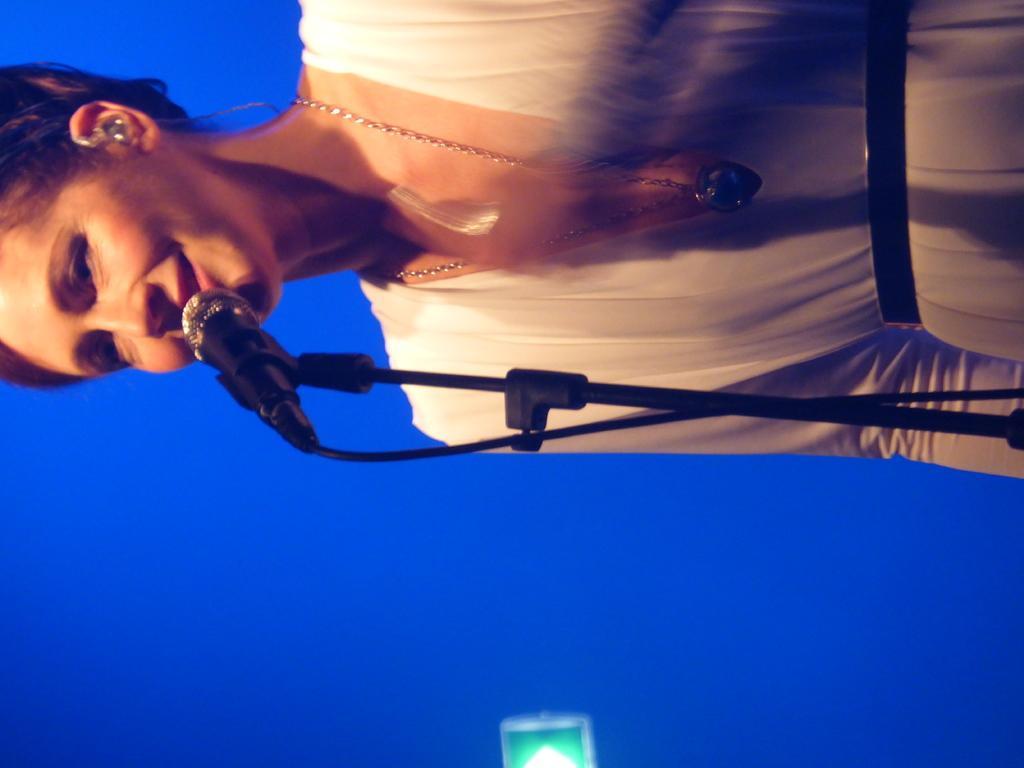Please provide a concise description of this image. In this image, we can see a person on the blue background. There is a mic in front of the person. 